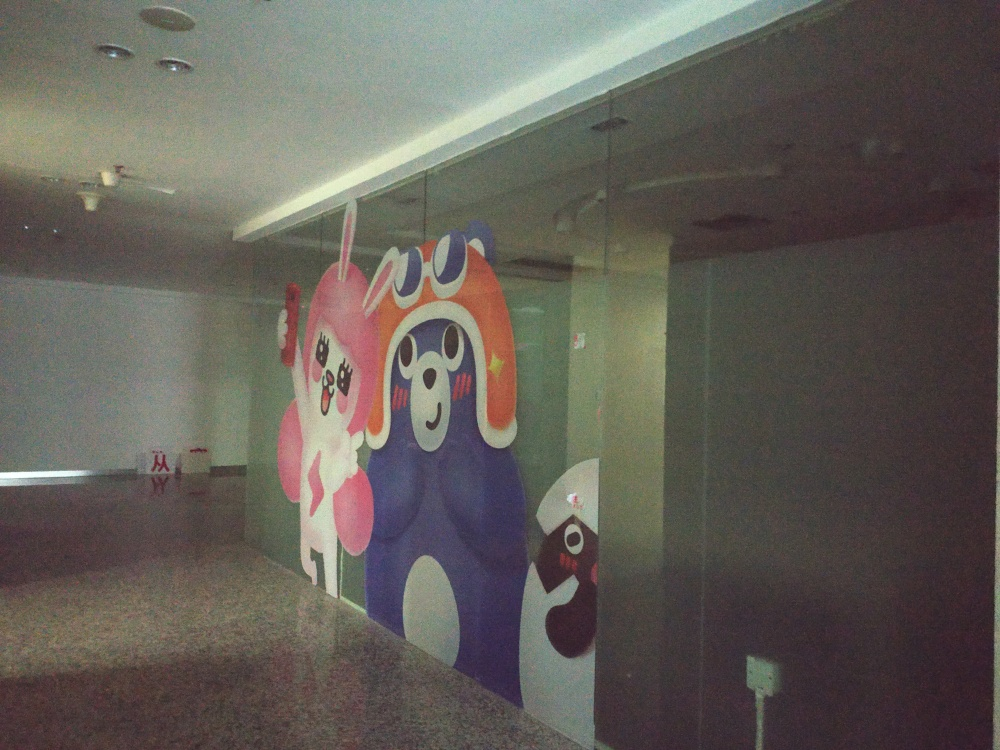What emotions do the characters in the mural seem to portray? The characters in the mural exhibit a range of emotions that add to their whimsical nature. Some characters appear joyful and inviting with their wide smiles, while others seem more mysterious or playful. These varying expressions contribute to a dynamic and lively feel to the artwork, creating an interactive experience for the viewer. 